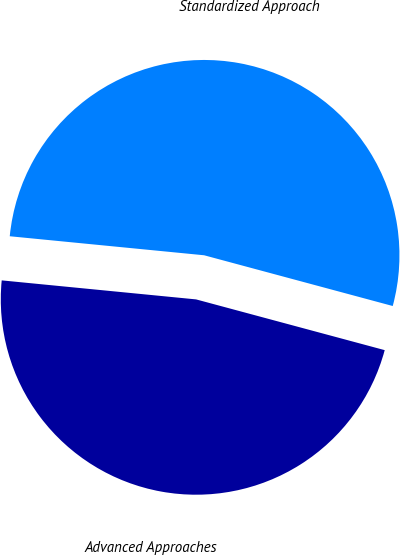Convert chart. <chart><loc_0><loc_0><loc_500><loc_500><pie_chart><fcel>Advanced Approaches<fcel>Standardized Approach<nl><fcel>47.37%<fcel>52.63%<nl></chart> 